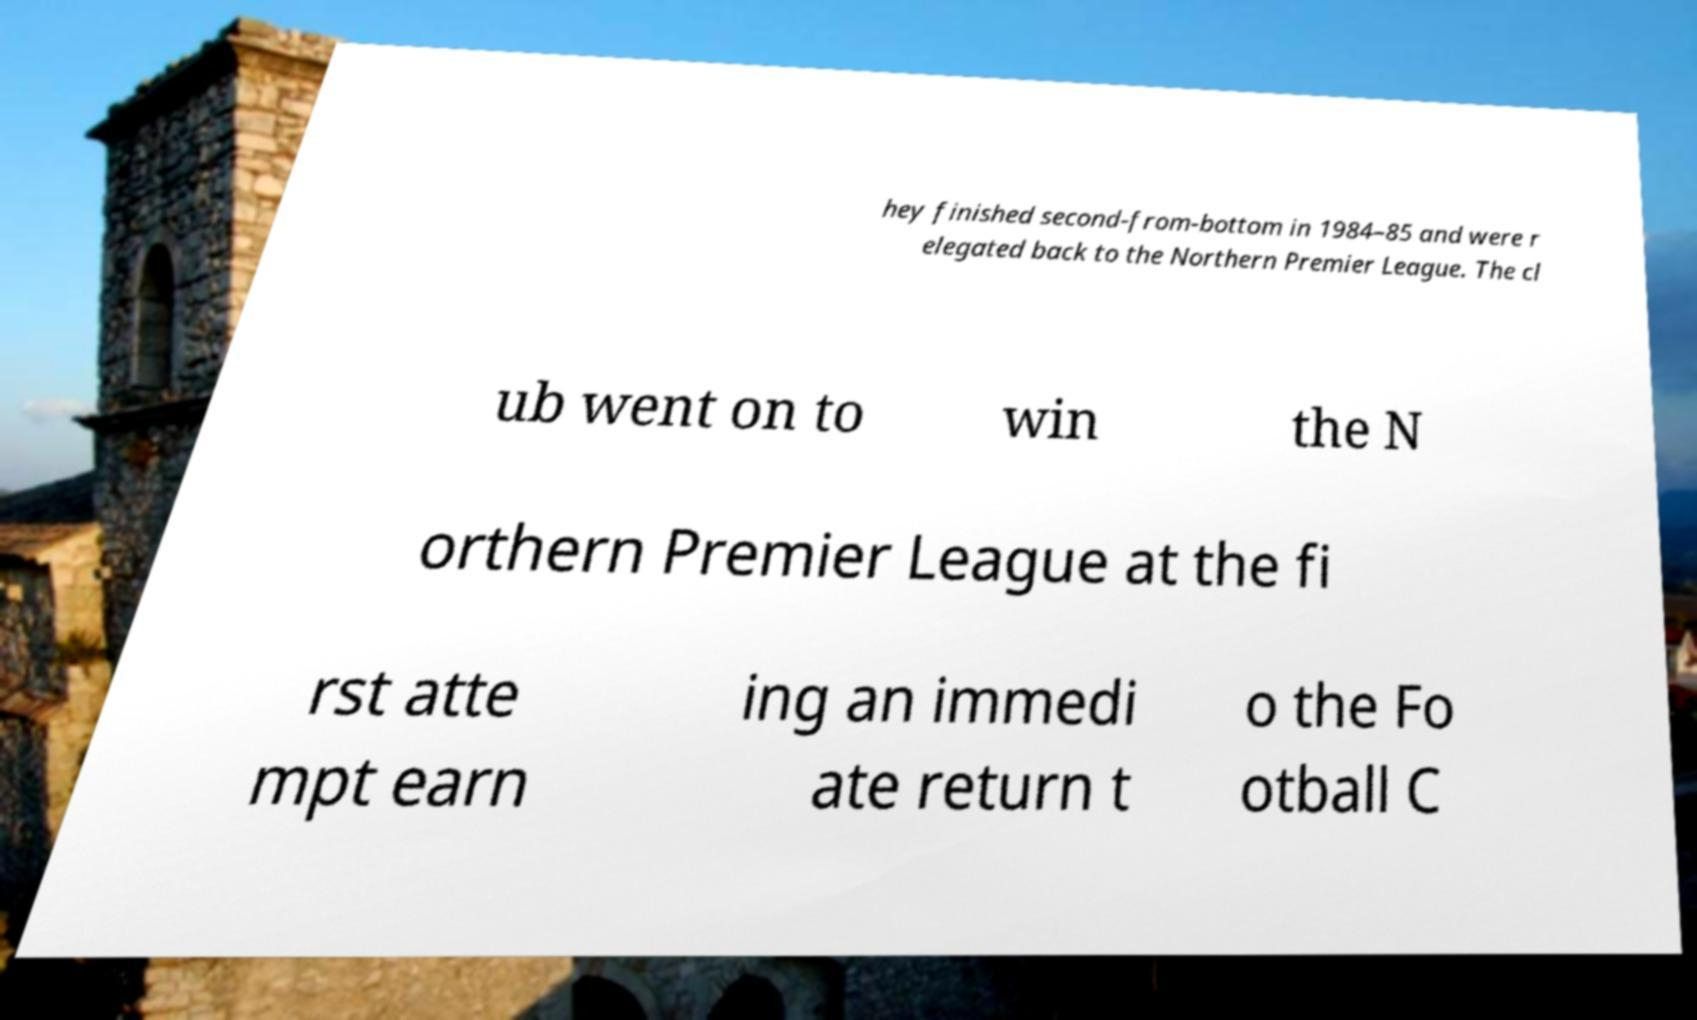Could you extract and type out the text from this image? hey finished second-from-bottom in 1984–85 and were r elegated back to the Northern Premier League. The cl ub went on to win the N orthern Premier League at the fi rst atte mpt earn ing an immedi ate return t o the Fo otball C 